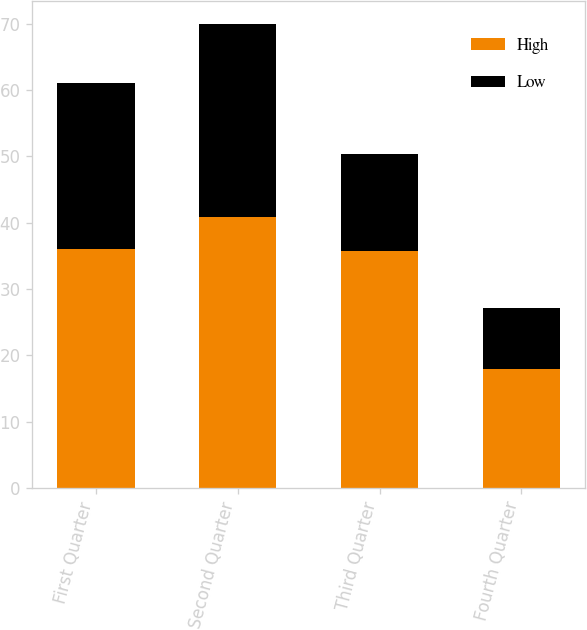<chart> <loc_0><loc_0><loc_500><loc_500><stacked_bar_chart><ecel><fcel>First Quarter<fcel>Second Quarter<fcel>Third Quarter<fcel>Fourth Quarter<nl><fcel>High<fcel>36<fcel>40.9<fcel>35.72<fcel>17.95<nl><fcel>Low<fcel>25.06<fcel>29.02<fcel>14.6<fcel>9.25<nl></chart> 